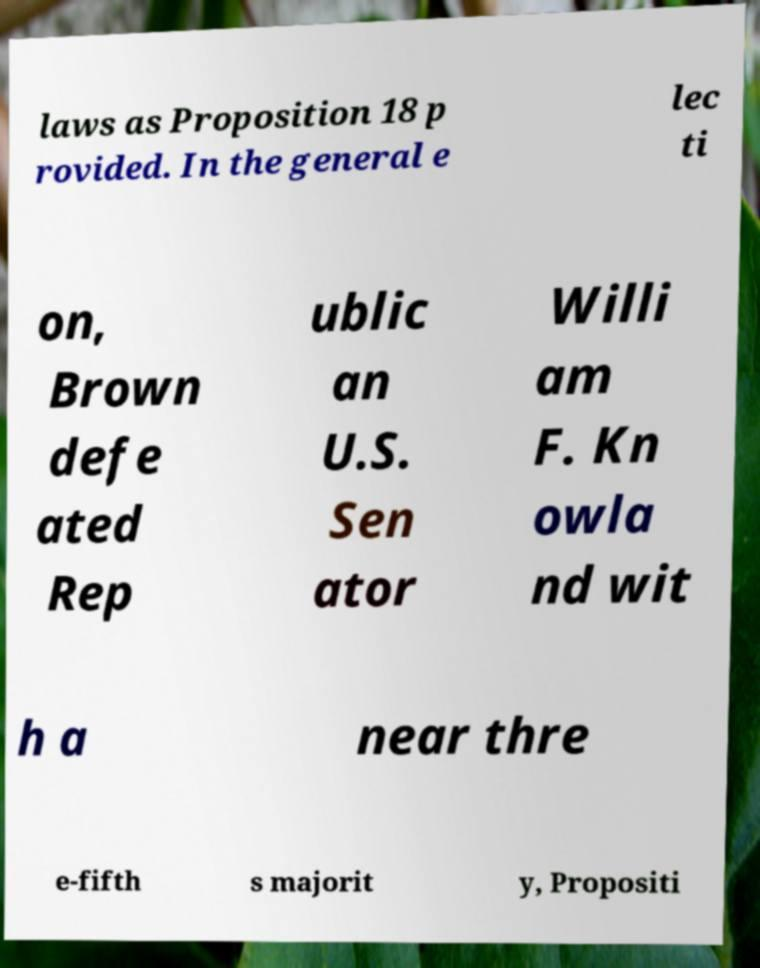Could you assist in decoding the text presented in this image and type it out clearly? laws as Proposition 18 p rovided. In the general e lec ti on, Brown defe ated Rep ublic an U.S. Sen ator Willi am F. Kn owla nd wit h a near thre e-fifth s majorit y, Propositi 